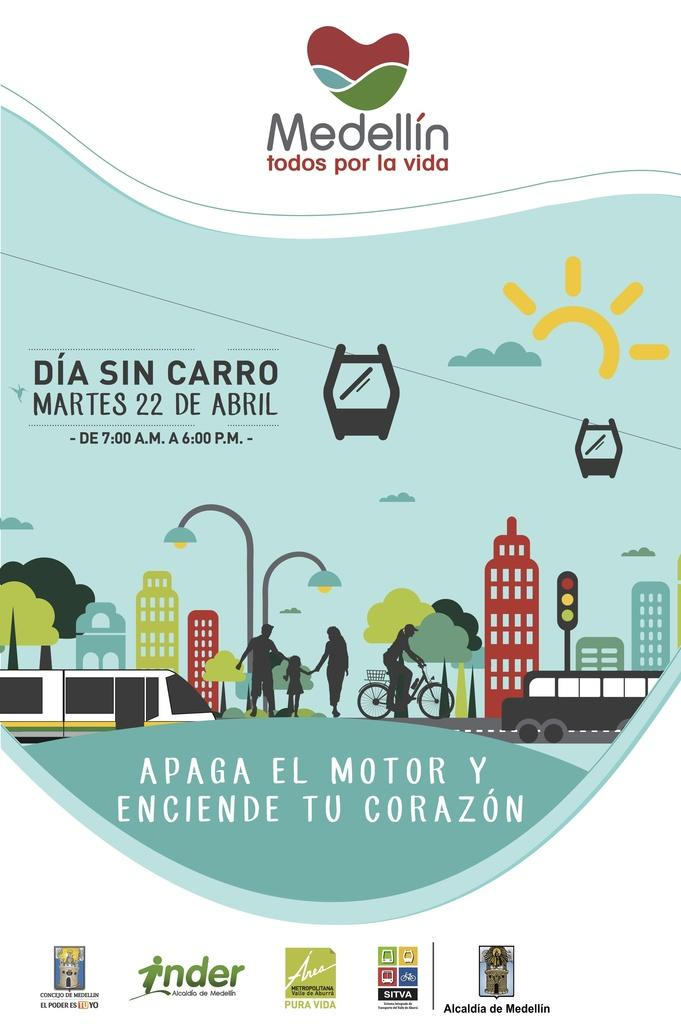<image>
Write a terse but informative summary of the picture. People outside in the city and the company name Medellin above them 